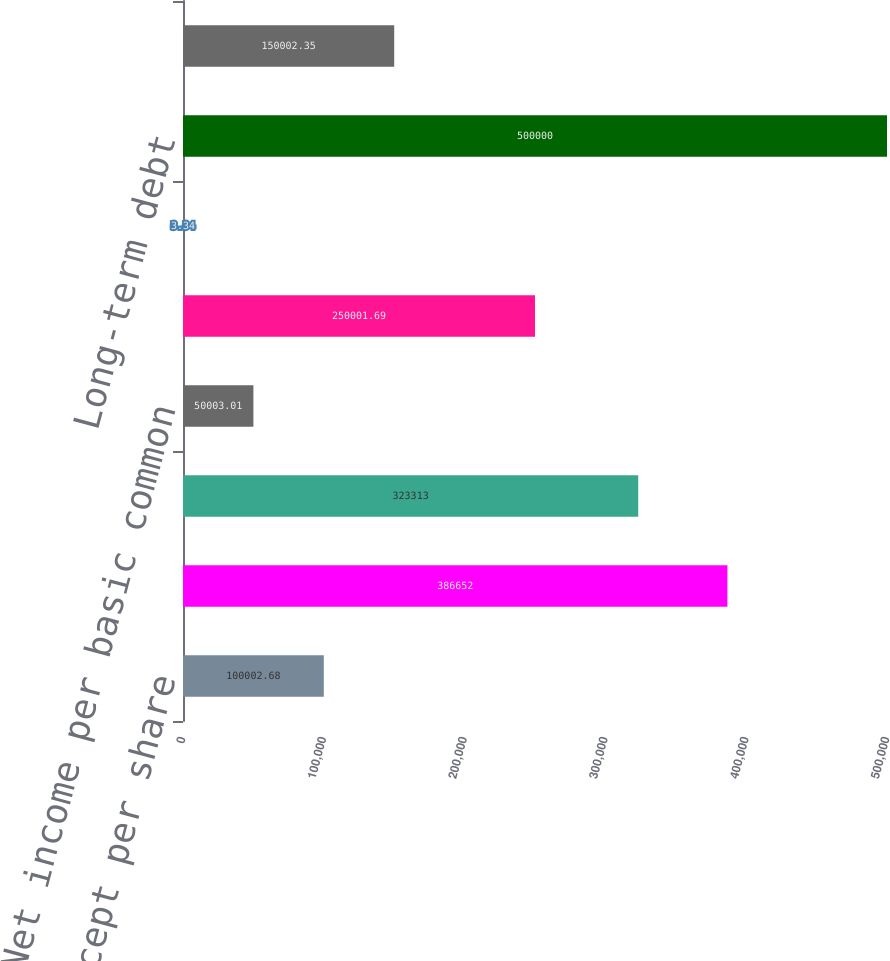Convert chart. <chart><loc_0><loc_0><loc_500><loc_500><bar_chart><fcel>In thousands except per share<fcel>Income from operations before<fcel>Net income<fcel>Net income per basic common<fcel>Weighted-average number of<fcel>Net income per diluted common<fcel>Long-term debt<fcel>Employees<nl><fcel>100003<fcel>386652<fcel>323313<fcel>50003<fcel>250002<fcel>3.34<fcel>500000<fcel>150002<nl></chart> 